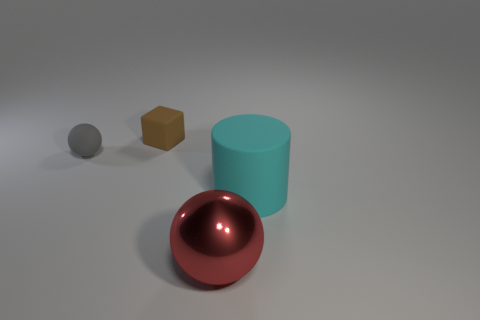Add 4 large red things. How many objects exist? 8 Subtract all red spheres. How many spheres are left? 1 Subtract all blocks. How many objects are left? 3 Add 3 brown cubes. How many brown cubes are left? 4 Add 1 small gray matte balls. How many small gray matte balls exist? 2 Subtract 0 purple spheres. How many objects are left? 4 Subtract all gray spheres. Subtract all yellow cylinders. How many spheres are left? 1 Subtract all large red metal cubes. Subtract all small blocks. How many objects are left? 3 